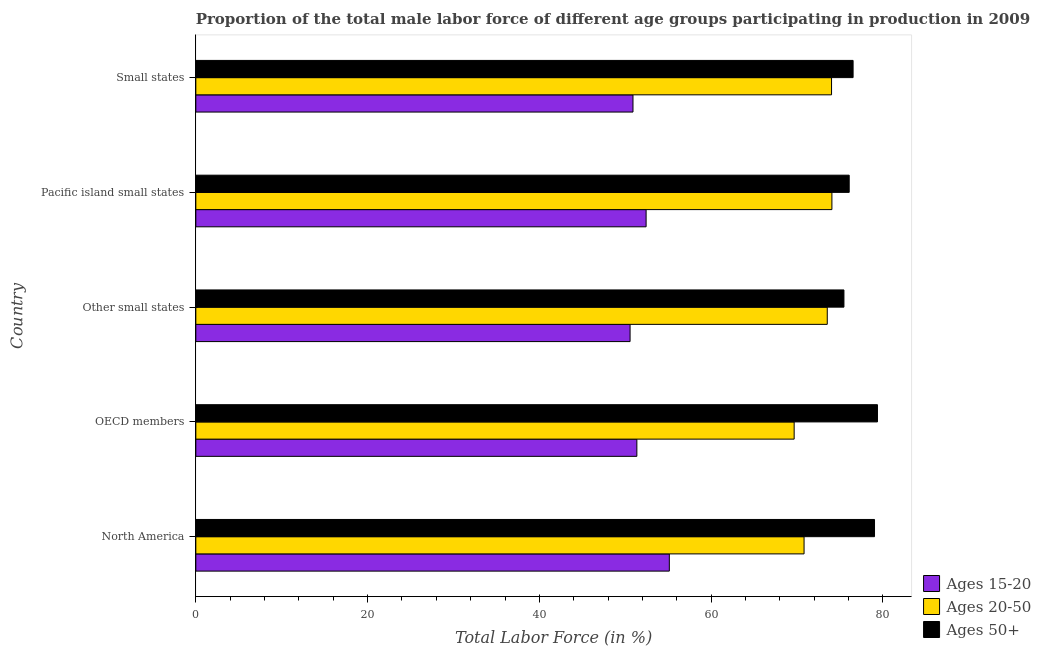Are the number of bars per tick equal to the number of legend labels?
Your response must be concise. Yes. Are the number of bars on each tick of the Y-axis equal?
Make the answer very short. Yes. How many bars are there on the 2nd tick from the top?
Your answer should be compact. 3. In how many cases, is the number of bars for a given country not equal to the number of legend labels?
Offer a very short reply. 0. What is the percentage of male labor force within the age group 15-20 in Small states?
Your response must be concise. 50.89. Across all countries, what is the maximum percentage of male labor force within the age group 15-20?
Offer a terse response. 55.13. Across all countries, what is the minimum percentage of male labor force within the age group 15-20?
Keep it short and to the point. 50.56. In which country was the percentage of male labor force within the age group 15-20 maximum?
Provide a succinct answer. North America. In which country was the percentage of male labor force within the age group 15-20 minimum?
Offer a very short reply. Other small states. What is the total percentage of male labor force within the age group 15-20 in the graph?
Make the answer very short. 260.34. What is the difference between the percentage of male labor force within the age group 15-20 in North America and that in Other small states?
Ensure brevity in your answer.  4.57. What is the difference between the percentage of male labor force within the age group 15-20 in Pacific island small states and the percentage of male labor force above age 50 in OECD members?
Keep it short and to the point. -26.94. What is the average percentage of male labor force within the age group 15-20 per country?
Give a very brief answer. 52.07. What is the difference between the percentage of male labor force within the age group 15-20 and percentage of male labor force above age 50 in Other small states?
Give a very brief answer. -24.9. What is the ratio of the percentage of male labor force within the age group 15-20 in North America to that in Small states?
Your response must be concise. 1.08. What is the difference between the highest and the second highest percentage of male labor force within the age group 20-50?
Provide a short and direct response. 0.04. In how many countries, is the percentage of male labor force within the age group 20-50 greater than the average percentage of male labor force within the age group 20-50 taken over all countries?
Give a very brief answer. 3. What does the 2nd bar from the top in North America represents?
Your answer should be compact. Ages 20-50. What does the 1st bar from the bottom in Small states represents?
Keep it short and to the point. Ages 15-20. Are all the bars in the graph horizontal?
Your answer should be compact. Yes. How many countries are there in the graph?
Keep it short and to the point. 5. What is the difference between two consecutive major ticks on the X-axis?
Your response must be concise. 20. Are the values on the major ticks of X-axis written in scientific E-notation?
Your answer should be very brief. No. How many legend labels are there?
Ensure brevity in your answer.  3. How are the legend labels stacked?
Make the answer very short. Vertical. What is the title of the graph?
Ensure brevity in your answer.  Proportion of the total male labor force of different age groups participating in production in 2009. What is the label or title of the X-axis?
Your answer should be very brief. Total Labor Force (in %). What is the label or title of the Y-axis?
Give a very brief answer. Country. What is the Total Labor Force (in %) in Ages 15-20 in North America?
Give a very brief answer. 55.13. What is the Total Labor Force (in %) in Ages 20-50 in North America?
Offer a terse response. 70.81. What is the Total Labor Force (in %) in Ages 50+ in North America?
Provide a short and direct response. 79.02. What is the Total Labor Force (in %) of Ages 15-20 in OECD members?
Provide a short and direct response. 51.35. What is the Total Labor Force (in %) in Ages 20-50 in OECD members?
Offer a very short reply. 69.66. What is the Total Labor Force (in %) of Ages 50+ in OECD members?
Ensure brevity in your answer.  79.36. What is the Total Labor Force (in %) of Ages 15-20 in Other small states?
Ensure brevity in your answer.  50.56. What is the Total Labor Force (in %) in Ages 20-50 in Other small states?
Give a very brief answer. 73.51. What is the Total Labor Force (in %) in Ages 50+ in Other small states?
Offer a very short reply. 75.46. What is the Total Labor Force (in %) in Ages 15-20 in Pacific island small states?
Keep it short and to the point. 52.42. What is the Total Labor Force (in %) of Ages 20-50 in Pacific island small states?
Keep it short and to the point. 74.05. What is the Total Labor Force (in %) in Ages 50+ in Pacific island small states?
Your answer should be compact. 76.07. What is the Total Labor Force (in %) of Ages 15-20 in Small states?
Make the answer very short. 50.89. What is the Total Labor Force (in %) of Ages 20-50 in Small states?
Offer a very short reply. 74.01. What is the Total Labor Force (in %) of Ages 50+ in Small states?
Offer a terse response. 76.52. Across all countries, what is the maximum Total Labor Force (in %) of Ages 15-20?
Provide a succinct answer. 55.13. Across all countries, what is the maximum Total Labor Force (in %) of Ages 20-50?
Your answer should be compact. 74.05. Across all countries, what is the maximum Total Labor Force (in %) in Ages 50+?
Keep it short and to the point. 79.36. Across all countries, what is the minimum Total Labor Force (in %) in Ages 15-20?
Make the answer very short. 50.56. Across all countries, what is the minimum Total Labor Force (in %) of Ages 20-50?
Offer a very short reply. 69.66. Across all countries, what is the minimum Total Labor Force (in %) in Ages 50+?
Your response must be concise. 75.46. What is the total Total Labor Force (in %) in Ages 15-20 in the graph?
Keep it short and to the point. 260.34. What is the total Total Labor Force (in %) in Ages 20-50 in the graph?
Offer a very short reply. 362.05. What is the total Total Labor Force (in %) in Ages 50+ in the graph?
Your response must be concise. 386.42. What is the difference between the Total Labor Force (in %) in Ages 15-20 in North America and that in OECD members?
Your response must be concise. 3.78. What is the difference between the Total Labor Force (in %) in Ages 20-50 in North America and that in OECD members?
Offer a very short reply. 1.15. What is the difference between the Total Labor Force (in %) of Ages 50+ in North America and that in OECD members?
Make the answer very short. -0.34. What is the difference between the Total Labor Force (in %) in Ages 15-20 in North America and that in Other small states?
Provide a succinct answer. 4.57. What is the difference between the Total Labor Force (in %) in Ages 20-50 in North America and that in Other small states?
Make the answer very short. -2.7. What is the difference between the Total Labor Force (in %) in Ages 50+ in North America and that in Other small states?
Make the answer very short. 3.56. What is the difference between the Total Labor Force (in %) of Ages 15-20 in North America and that in Pacific island small states?
Keep it short and to the point. 2.7. What is the difference between the Total Labor Force (in %) in Ages 20-50 in North America and that in Pacific island small states?
Give a very brief answer. -3.24. What is the difference between the Total Labor Force (in %) in Ages 50+ in North America and that in Pacific island small states?
Give a very brief answer. 2.95. What is the difference between the Total Labor Force (in %) in Ages 15-20 in North America and that in Small states?
Give a very brief answer. 4.23. What is the difference between the Total Labor Force (in %) of Ages 20-50 in North America and that in Small states?
Keep it short and to the point. -3.2. What is the difference between the Total Labor Force (in %) of Ages 50+ in North America and that in Small states?
Your answer should be very brief. 2.49. What is the difference between the Total Labor Force (in %) in Ages 15-20 in OECD members and that in Other small states?
Your response must be concise. 0.79. What is the difference between the Total Labor Force (in %) in Ages 20-50 in OECD members and that in Other small states?
Give a very brief answer. -3.86. What is the difference between the Total Labor Force (in %) in Ages 50+ in OECD members and that in Other small states?
Make the answer very short. 3.9. What is the difference between the Total Labor Force (in %) in Ages 15-20 in OECD members and that in Pacific island small states?
Offer a very short reply. -1.08. What is the difference between the Total Labor Force (in %) in Ages 20-50 in OECD members and that in Pacific island small states?
Give a very brief answer. -4.4. What is the difference between the Total Labor Force (in %) in Ages 50+ in OECD members and that in Pacific island small states?
Provide a short and direct response. 3.29. What is the difference between the Total Labor Force (in %) of Ages 15-20 in OECD members and that in Small states?
Give a very brief answer. 0.45. What is the difference between the Total Labor Force (in %) of Ages 20-50 in OECD members and that in Small states?
Ensure brevity in your answer.  -4.35. What is the difference between the Total Labor Force (in %) in Ages 50+ in OECD members and that in Small states?
Keep it short and to the point. 2.84. What is the difference between the Total Labor Force (in %) in Ages 15-20 in Other small states and that in Pacific island small states?
Your response must be concise. -1.87. What is the difference between the Total Labor Force (in %) in Ages 20-50 in Other small states and that in Pacific island small states?
Make the answer very short. -0.54. What is the difference between the Total Labor Force (in %) in Ages 50+ in Other small states and that in Pacific island small states?
Give a very brief answer. -0.61. What is the difference between the Total Labor Force (in %) in Ages 15-20 in Other small states and that in Small states?
Provide a succinct answer. -0.34. What is the difference between the Total Labor Force (in %) of Ages 20-50 in Other small states and that in Small states?
Give a very brief answer. -0.5. What is the difference between the Total Labor Force (in %) of Ages 50+ in Other small states and that in Small states?
Offer a terse response. -1.07. What is the difference between the Total Labor Force (in %) of Ages 15-20 in Pacific island small states and that in Small states?
Offer a very short reply. 1.53. What is the difference between the Total Labor Force (in %) in Ages 20-50 in Pacific island small states and that in Small states?
Your answer should be very brief. 0.04. What is the difference between the Total Labor Force (in %) of Ages 50+ in Pacific island small states and that in Small states?
Your answer should be very brief. -0.45. What is the difference between the Total Labor Force (in %) in Ages 15-20 in North America and the Total Labor Force (in %) in Ages 20-50 in OECD members?
Offer a very short reply. -14.53. What is the difference between the Total Labor Force (in %) in Ages 15-20 in North America and the Total Labor Force (in %) in Ages 50+ in OECD members?
Your response must be concise. -24.23. What is the difference between the Total Labor Force (in %) in Ages 20-50 in North America and the Total Labor Force (in %) in Ages 50+ in OECD members?
Your answer should be very brief. -8.55. What is the difference between the Total Labor Force (in %) of Ages 15-20 in North America and the Total Labor Force (in %) of Ages 20-50 in Other small states?
Your answer should be compact. -18.39. What is the difference between the Total Labor Force (in %) in Ages 15-20 in North America and the Total Labor Force (in %) in Ages 50+ in Other small states?
Your answer should be very brief. -20.33. What is the difference between the Total Labor Force (in %) of Ages 20-50 in North America and the Total Labor Force (in %) of Ages 50+ in Other small states?
Ensure brevity in your answer.  -4.64. What is the difference between the Total Labor Force (in %) of Ages 15-20 in North America and the Total Labor Force (in %) of Ages 20-50 in Pacific island small states?
Your response must be concise. -18.93. What is the difference between the Total Labor Force (in %) of Ages 15-20 in North America and the Total Labor Force (in %) of Ages 50+ in Pacific island small states?
Offer a very short reply. -20.94. What is the difference between the Total Labor Force (in %) of Ages 20-50 in North America and the Total Labor Force (in %) of Ages 50+ in Pacific island small states?
Provide a short and direct response. -5.25. What is the difference between the Total Labor Force (in %) of Ages 15-20 in North America and the Total Labor Force (in %) of Ages 20-50 in Small states?
Your answer should be very brief. -18.89. What is the difference between the Total Labor Force (in %) in Ages 15-20 in North America and the Total Labor Force (in %) in Ages 50+ in Small states?
Provide a succinct answer. -21.4. What is the difference between the Total Labor Force (in %) in Ages 20-50 in North America and the Total Labor Force (in %) in Ages 50+ in Small states?
Give a very brief answer. -5.71. What is the difference between the Total Labor Force (in %) in Ages 15-20 in OECD members and the Total Labor Force (in %) in Ages 20-50 in Other small states?
Give a very brief answer. -22.17. What is the difference between the Total Labor Force (in %) in Ages 15-20 in OECD members and the Total Labor Force (in %) in Ages 50+ in Other small states?
Offer a terse response. -24.11. What is the difference between the Total Labor Force (in %) of Ages 20-50 in OECD members and the Total Labor Force (in %) of Ages 50+ in Other small states?
Keep it short and to the point. -5.8. What is the difference between the Total Labor Force (in %) in Ages 15-20 in OECD members and the Total Labor Force (in %) in Ages 20-50 in Pacific island small states?
Your response must be concise. -22.71. What is the difference between the Total Labor Force (in %) of Ages 15-20 in OECD members and the Total Labor Force (in %) of Ages 50+ in Pacific island small states?
Offer a terse response. -24.72. What is the difference between the Total Labor Force (in %) of Ages 20-50 in OECD members and the Total Labor Force (in %) of Ages 50+ in Pacific island small states?
Provide a succinct answer. -6.41. What is the difference between the Total Labor Force (in %) of Ages 15-20 in OECD members and the Total Labor Force (in %) of Ages 20-50 in Small states?
Provide a succinct answer. -22.67. What is the difference between the Total Labor Force (in %) in Ages 15-20 in OECD members and the Total Labor Force (in %) in Ages 50+ in Small states?
Make the answer very short. -25.18. What is the difference between the Total Labor Force (in %) of Ages 20-50 in OECD members and the Total Labor Force (in %) of Ages 50+ in Small states?
Give a very brief answer. -6.86. What is the difference between the Total Labor Force (in %) of Ages 15-20 in Other small states and the Total Labor Force (in %) of Ages 20-50 in Pacific island small states?
Make the answer very short. -23.5. What is the difference between the Total Labor Force (in %) of Ages 15-20 in Other small states and the Total Labor Force (in %) of Ages 50+ in Pacific island small states?
Keep it short and to the point. -25.51. What is the difference between the Total Labor Force (in %) of Ages 20-50 in Other small states and the Total Labor Force (in %) of Ages 50+ in Pacific island small states?
Give a very brief answer. -2.55. What is the difference between the Total Labor Force (in %) in Ages 15-20 in Other small states and the Total Labor Force (in %) in Ages 20-50 in Small states?
Offer a very short reply. -23.46. What is the difference between the Total Labor Force (in %) in Ages 15-20 in Other small states and the Total Labor Force (in %) in Ages 50+ in Small states?
Provide a succinct answer. -25.96. What is the difference between the Total Labor Force (in %) in Ages 20-50 in Other small states and the Total Labor Force (in %) in Ages 50+ in Small states?
Your answer should be compact. -3.01. What is the difference between the Total Labor Force (in %) of Ages 15-20 in Pacific island small states and the Total Labor Force (in %) of Ages 20-50 in Small states?
Your answer should be very brief. -21.59. What is the difference between the Total Labor Force (in %) in Ages 15-20 in Pacific island small states and the Total Labor Force (in %) in Ages 50+ in Small states?
Give a very brief answer. -24.1. What is the difference between the Total Labor Force (in %) of Ages 20-50 in Pacific island small states and the Total Labor Force (in %) of Ages 50+ in Small states?
Your answer should be very brief. -2.47. What is the average Total Labor Force (in %) of Ages 15-20 per country?
Ensure brevity in your answer.  52.07. What is the average Total Labor Force (in %) of Ages 20-50 per country?
Your answer should be very brief. 72.41. What is the average Total Labor Force (in %) of Ages 50+ per country?
Your answer should be compact. 77.28. What is the difference between the Total Labor Force (in %) in Ages 15-20 and Total Labor Force (in %) in Ages 20-50 in North America?
Provide a short and direct response. -15.69. What is the difference between the Total Labor Force (in %) in Ages 15-20 and Total Labor Force (in %) in Ages 50+ in North America?
Offer a terse response. -23.89. What is the difference between the Total Labor Force (in %) of Ages 20-50 and Total Labor Force (in %) of Ages 50+ in North America?
Ensure brevity in your answer.  -8.2. What is the difference between the Total Labor Force (in %) of Ages 15-20 and Total Labor Force (in %) of Ages 20-50 in OECD members?
Ensure brevity in your answer.  -18.31. What is the difference between the Total Labor Force (in %) in Ages 15-20 and Total Labor Force (in %) in Ages 50+ in OECD members?
Your answer should be very brief. -28.01. What is the difference between the Total Labor Force (in %) of Ages 20-50 and Total Labor Force (in %) of Ages 50+ in OECD members?
Give a very brief answer. -9.7. What is the difference between the Total Labor Force (in %) of Ages 15-20 and Total Labor Force (in %) of Ages 20-50 in Other small states?
Ensure brevity in your answer.  -22.96. What is the difference between the Total Labor Force (in %) of Ages 15-20 and Total Labor Force (in %) of Ages 50+ in Other small states?
Provide a succinct answer. -24.9. What is the difference between the Total Labor Force (in %) in Ages 20-50 and Total Labor Force (in %) in Ages 50+ in Other small states?
Your response must be concise. -1.94. What is the difference between the Total Labor Force (in %) of Ages 15-20 and Total Labor Force (in %) of Ages 20-50 in Pacific island small states?
Your response must be concise. -21.63. What is the difference between the Total Labor Force (in %) in Ages 15-20 and Total Labor Force (in %) in Ages 50+ in Pacific island small states?
Your response must be concise. -23.65. What is the difference between the Total Labor Force (in %) of Ages 20-50 and Total Labor Force (in %) of Ages 50+ in Pacific island small states?
Your response must be concise. -2.01. What is the difference between the Total Labor Force (in %) in Ages 15-20 and Total Labor Force (in %) in Ages 20-50 in Small states?
Make the answer very short. -23.12. What is the difference between the Total Labor Force (in %) of Ages 15-20 and Total Labor Force (in %) of Ages 50+ in Small states?
Your answer should be compact. -25.63. What is the difference between the Total Labor Force (in %) of Ages 20-50 and Total Labor Force (in %) of Ages 50+ in Small states?
Offer a very short reply. -2.51. What is the ratio of the Total Labor Force (in %) of Ages 15-20 in North America to that in OECD members?
Keep it short and to the point. 1.07. What is the ratio of the Total Labor Force (in %) in Ages 20-50 in North America to that in OECD members?
Your answer should be very brief. 1.02. What is the ratio of the Total Labor Force (in %) in Ages 15-20 in North America to that in Other small states?
Make the answer very short. 1.09. What is the ratio of the Total Labor Force (in %) of Ages 20-50 in North America to that in Other small states?
Ensure brevity in your answer.  0.96. What is the ratio of the Total Labor Force (in %) of Ages 50+ in North America to that in Other small states?
Make the answer very short. 1.05. What is the ratio of the Total Labor Force (in %) of Ages 15-20 in North America to that in Pacific island small states?
Keep it short and to the point. 1.05. What is the ratio of the Total Labor Force (in %) of Ages 20-50 in North America to that in Pacific island small states?
Ensure brevity in your answer.  0.96. What is the ratio of the Total Labor Force (in %) of Ages 50+ in North America to that in Pacific island small states?
Offer a terse response. 1.04. What is the ratio of the Total Labor Force (in %) in Ages 15-20 in North America to that in Small states?
Make the answer very short. 1.08. What is the ratio of the Total Labor Force (in %) in Ages 20-50 in North America to that in Small states?
Offer a terse response. 0.96. What is the ratio of the Total Labor Force (in %) in Ages 50+ in North America to that in Small states?
Your answer should be very brief. 1.03. What is the ratio of the Total Labor Force (in %) in Ages 15-20 in OECD members to that in Other small states?
Provide a short and direct response. 1.02. What is the ratio of the Total Labor Force (in %) of Ages 20-50 in OECD members to that in Other small states?
Make the answer very short. 0.95. What is the ratio of the Total Labor Force (in %) of Ages 50+ in OECD members to that in Other small states?
Make the answer very short. 1.05. What is the ratio of the Total Labor Force (in %) in Ages 15-20 in OECD members to that in Pacific island small states?
Your response must be concise. 0.98. What is the ratio of the Total Labor Force (in %) in Ages 20-50 in OECD members to that in Pacific island small states?
Your answer should be compact. 0.94. What is the ratio of the Total Labor Force (in %) in Ages 50+ in OECD members to that in Pacific island small states?
Provide a short and direct response. 1.04. What is the ratio of the Total Labor Force (in %) of Ages 15-20 in OECD members to that in Small states?
Your response must be concise. 1.01. What is the ratio of the Total Labor Force (in %) of Ages 50+ in OECD members to that in Small states?
Your answer should be compact. 1.04. What is the ratio of the Total Labor Force (in %) in Ages 15-20 in Other small states to that in Pacific island small states?
Your response must be concise. 0.96. What is the ratio of the Total Labor Force (in %) of Ages 20-50 in Other small states to that in Pacific island small states?
Provide a short and direct response. 0.99. What is the ratio of the Total Labor Force (in %) of Ages 50+ in Other small states to that in Pacific island small states?
Ensure brevity in your answer.  0.99. What is the ratio of the Total Labor Force (in %) in Ages 15-20 in Other small states to that in Small states?
Provide a short and direct response. 0.99. What is the ratio of the Total Labor Force (in %) in Ages 50+ in Other small states to that in Small states?
Keep it short and to the point. 0.99. What is the ratio of the Total Labor Force (in %) in Ages 20-50 in Pacific island small states to that in Small states?
Your answer should be compact. 1. What is the difference between the highest and the second highest Total Labor Force (in %) of Ages 15-20?
Ensure brevity in your answer.  2.7. What is the difference between the highest and the second highest Total Labor Force (in %) in Ages 20-50?
Offer a terse response. 0.04. What is the difference between the highest and the second highest Total Labor Force (in %) in Ages 50+?
Make the answer very short. 0.34. What is the difference between the highest and the lowest Total Labor Force (in %) in Ages 15-20?
Your answer should be very brief. 4.57. What is the difference between the highest and the lowest Total Labor Force (in %) in Ages 20-50?
Provide a succinct answer. 4.4. What is the difference between the highest and the lowest Total Labor Force (in %) of Ages 50+?
Offer a terse response. 3.9. 